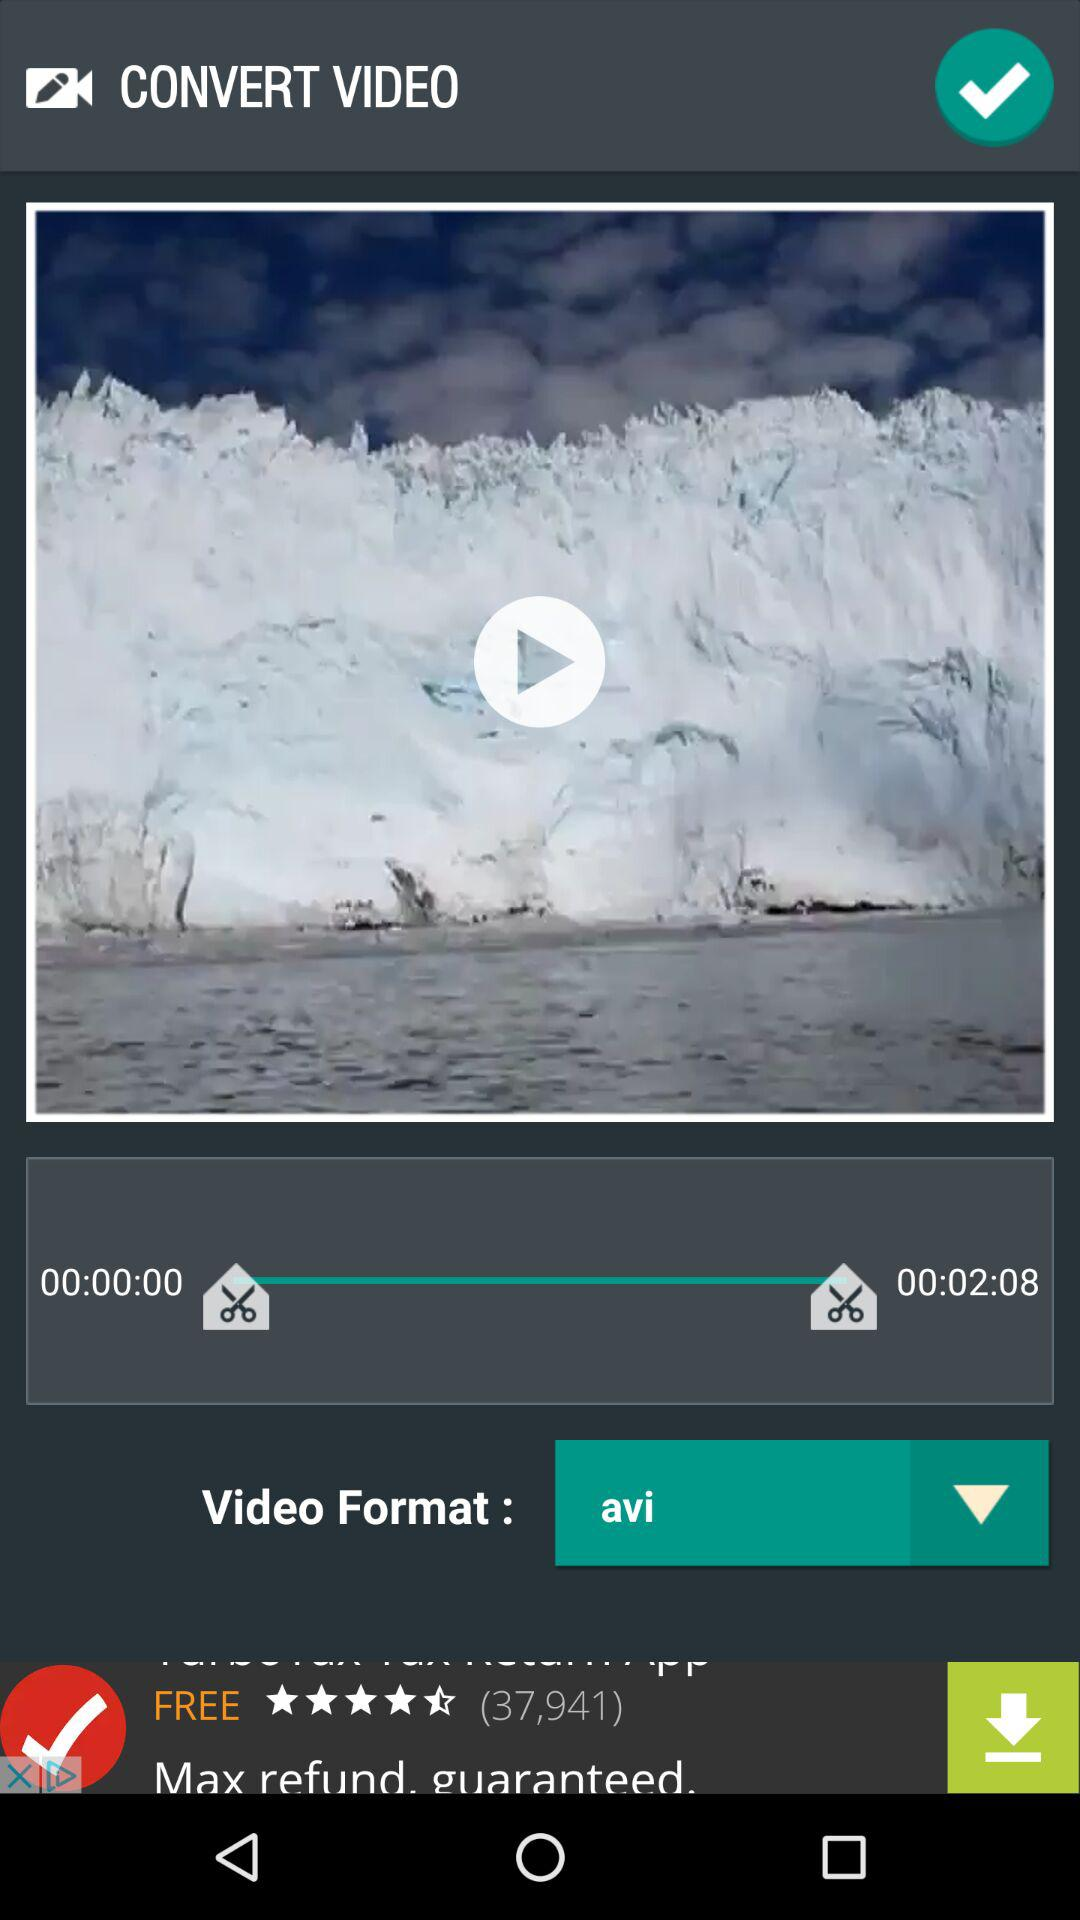How long is the video in seconds?
Answer the question using a single word or phrase. 128 